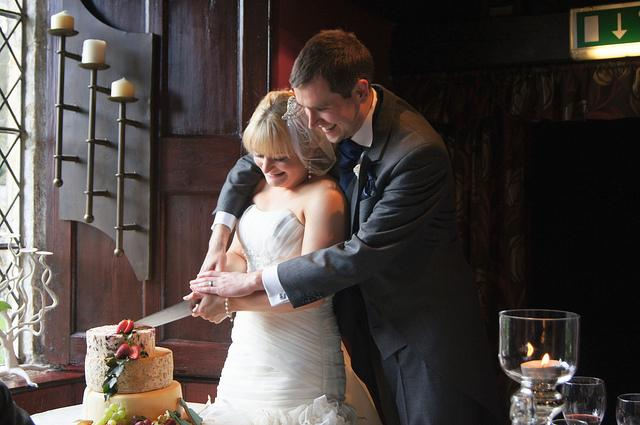What did the pair here recently exchange? vows 